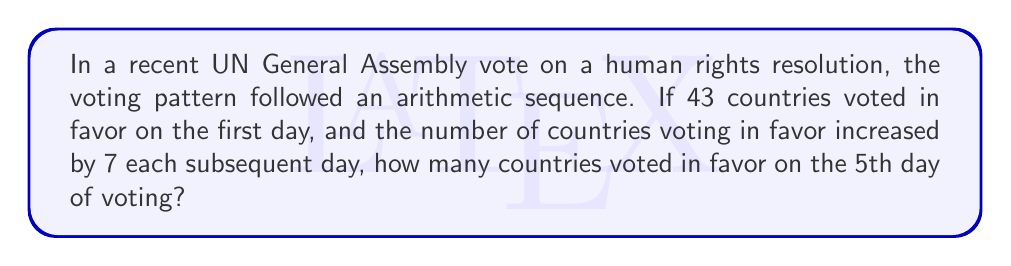Teach me how to tackle this problem. Let's approach this step-by-step using the arithmetic sequence formula:

1) In an arithmetic sequence, the nth term is given by:
   $a_n = a_1 + (n-1)d$
   Where:
   $a_n$ is the nth term
   $a_1$ is the first term
   $n$ is the position of the term
   $d$ is the common difference

2) We are given:
   $a_1 = 43$ (first day's votes)
   $d = 7$ (daily increase)
   $n = 5$ (we want the 5th day)

3) Substituting these values into the formula:
   $a_5 = 43 + (5-1)7$

4) Simplify:
   $a_5 = 43 + (4)7$
   $a_5 = 43 + 28$
   $a_5 = 71$

Therefore, on the 5th day of voting, 71 countries voted in favor of the resolution.
Answer: 71 countries 